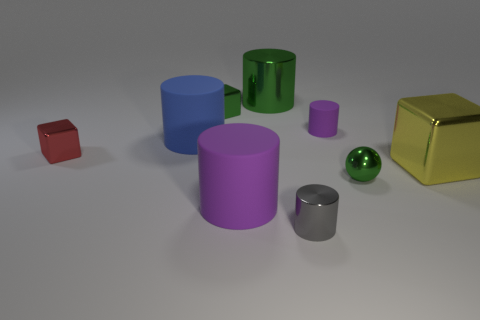What is the color of the tiny metal thing that is to the left of the tiny purple thing and to the right of the large purple rubber thing?
Provide a short and direct response. Gray. What shape is the tiny metallic object that is the same color as the ball?
Keep it short and to the point. Cube. How big is the purple cylinder in front of the purple rubber thing behind the yellow metal object?
Your response must be concise. Large. What number of blocks are either large metal things or tiny green metal objects?
Your response must be concise. 2. The matte object that is the same size as the metal ball is what color?
Keep it short and to the point. Purple. What is the shape of the purple object behind the small green metal thing on the right side of the big green metal cylinder?
Offer a very short reply. Cylinder. Do the purple thing in front of the red metallic block and the yellow shiny thing have the same size?
Offer a very short reply. Yes. How many other things are made of the same material as the blue cylinder?
Give a very brief answer. 2. How many green objects are shiny things or small shiny spheres?
Your answer should be very brief. 3. What is the size of the metallic block that is the same color as the shiny sphere?
Give a very brief answer. Small. 